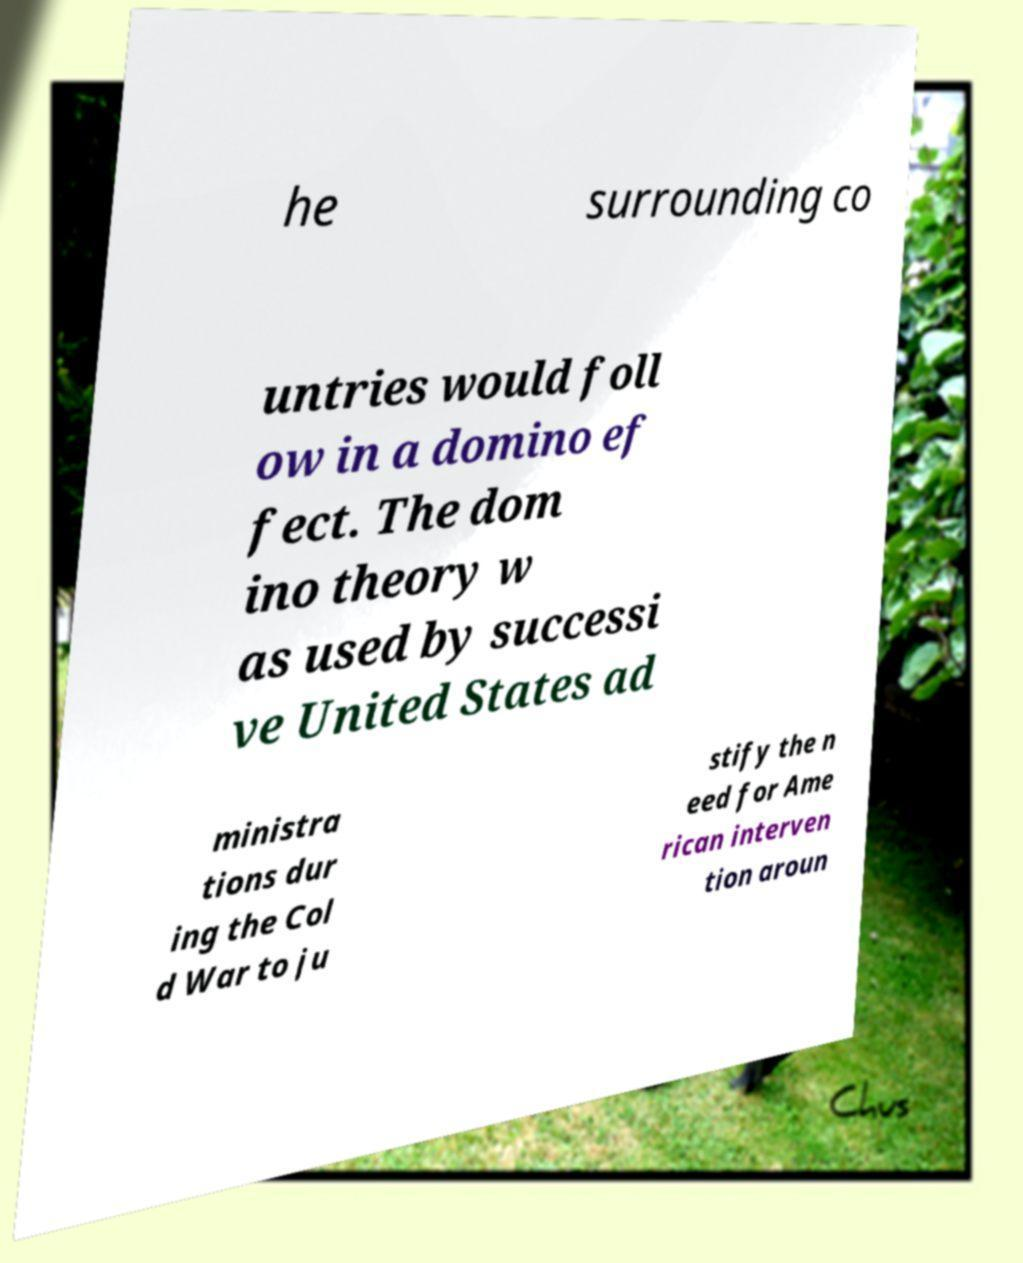Could you extract and type out the text from this image? he surrounding co untries would foll ow in a domino ef fect. The dom ino theory w as used by successi ve United States ad ministra tions dur ing the Col d War to ju stify the n eed for Ame rican interven tion aroun 